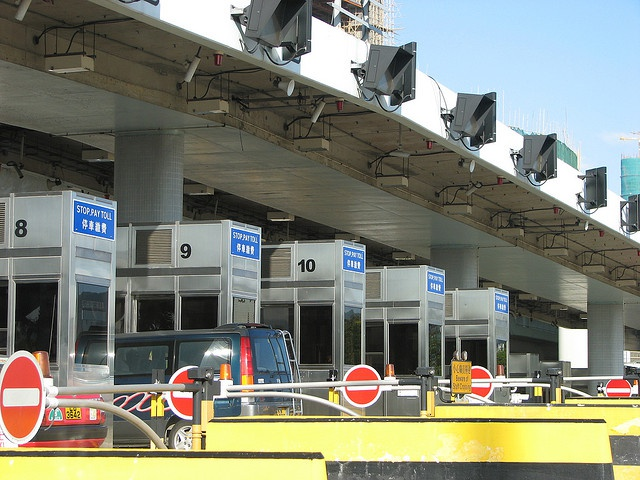Describe the objects in this image and their specific colors. I can see car in black, gray, blue, and white tones, stop sign in black, ivory, red, and lightpink tones, stop sign in black, red, white, and salmon tones, and stop sign in black, red, white, and salmon tones in this image. 